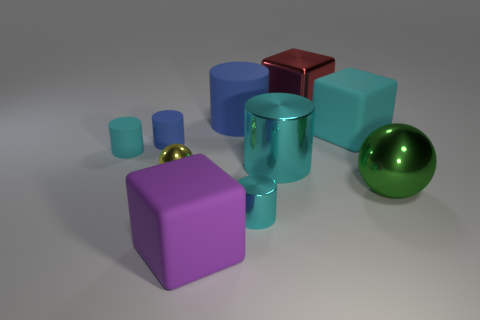Subtract all tiny cyan cylinders. How many cylinders are left? 3 Subtract all spheres. How many objects are left? 8 Add 3 big rubber blocks. How many big rubber blocks are left? 5 Add 6 cyan matte cubes. How many cyan matte cubes exist? 7 Subtract all red blocks. How many blocks are left? 2 Subtract 0 brown blocks. How many objects are left? 10 Subtract 3 cylinders. How many cylinders are left? 2 Subtract all red cylinders. Subtract all purple cubes. How many cylinders are left? 5 Subtract all cyan spheres. How many brown cylinders are left? 0 Subtract all small metal balls. Subtract all brown metallic blocks. How many objects are left? 9 